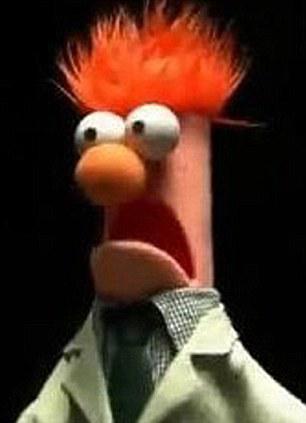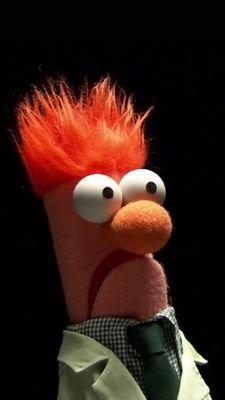The first image is the image on the left, the second image is the image on the right. Given the left and right images, does the statement "The puppet is facing to the right in the image on the right." hold true? Answer yes or no. Yes. 